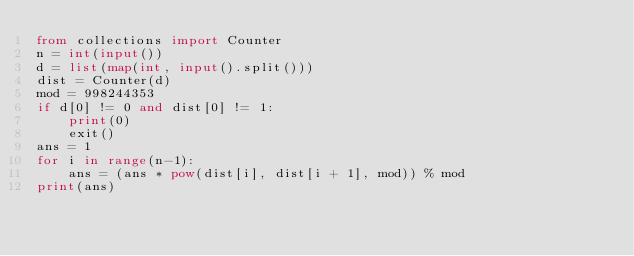Convert code to text. <code><loc_0><loc_0><loc_500><loc_500><_Python_>from collections import Counter
n = int(input())
d = list(map(int, input().split()))
dist = Counter(d)
mod = 998244353
if d[0] != 0 and dist[0] != 1:
    print(0)
    exit()
ans = 1
for i in range(n-1):
    ans = (ans * pow(dist[i], dist[i + 1], mod)) % mod
print(ans)
</code> 